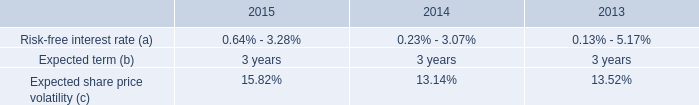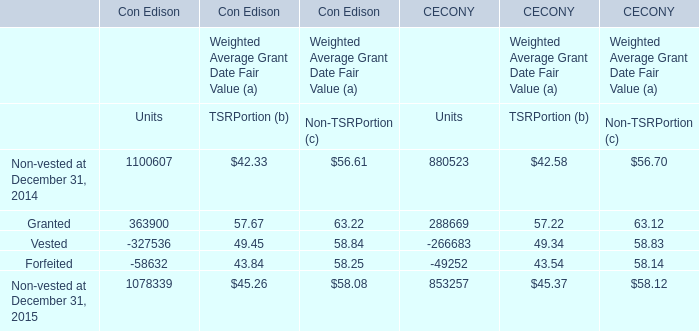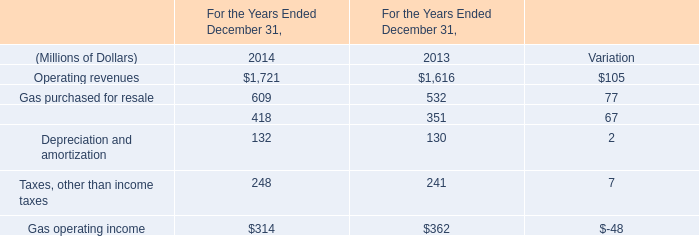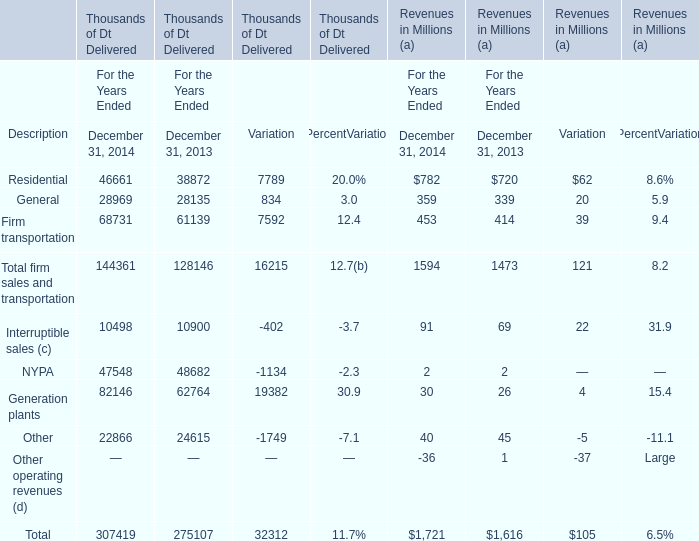What is the proportion of all Gas purchased for resale that are greater than 100 to the total amount of Operating revenues, in 2014? (in million) 
Computations: (609 / 1721)
Answer: 0.35386. 